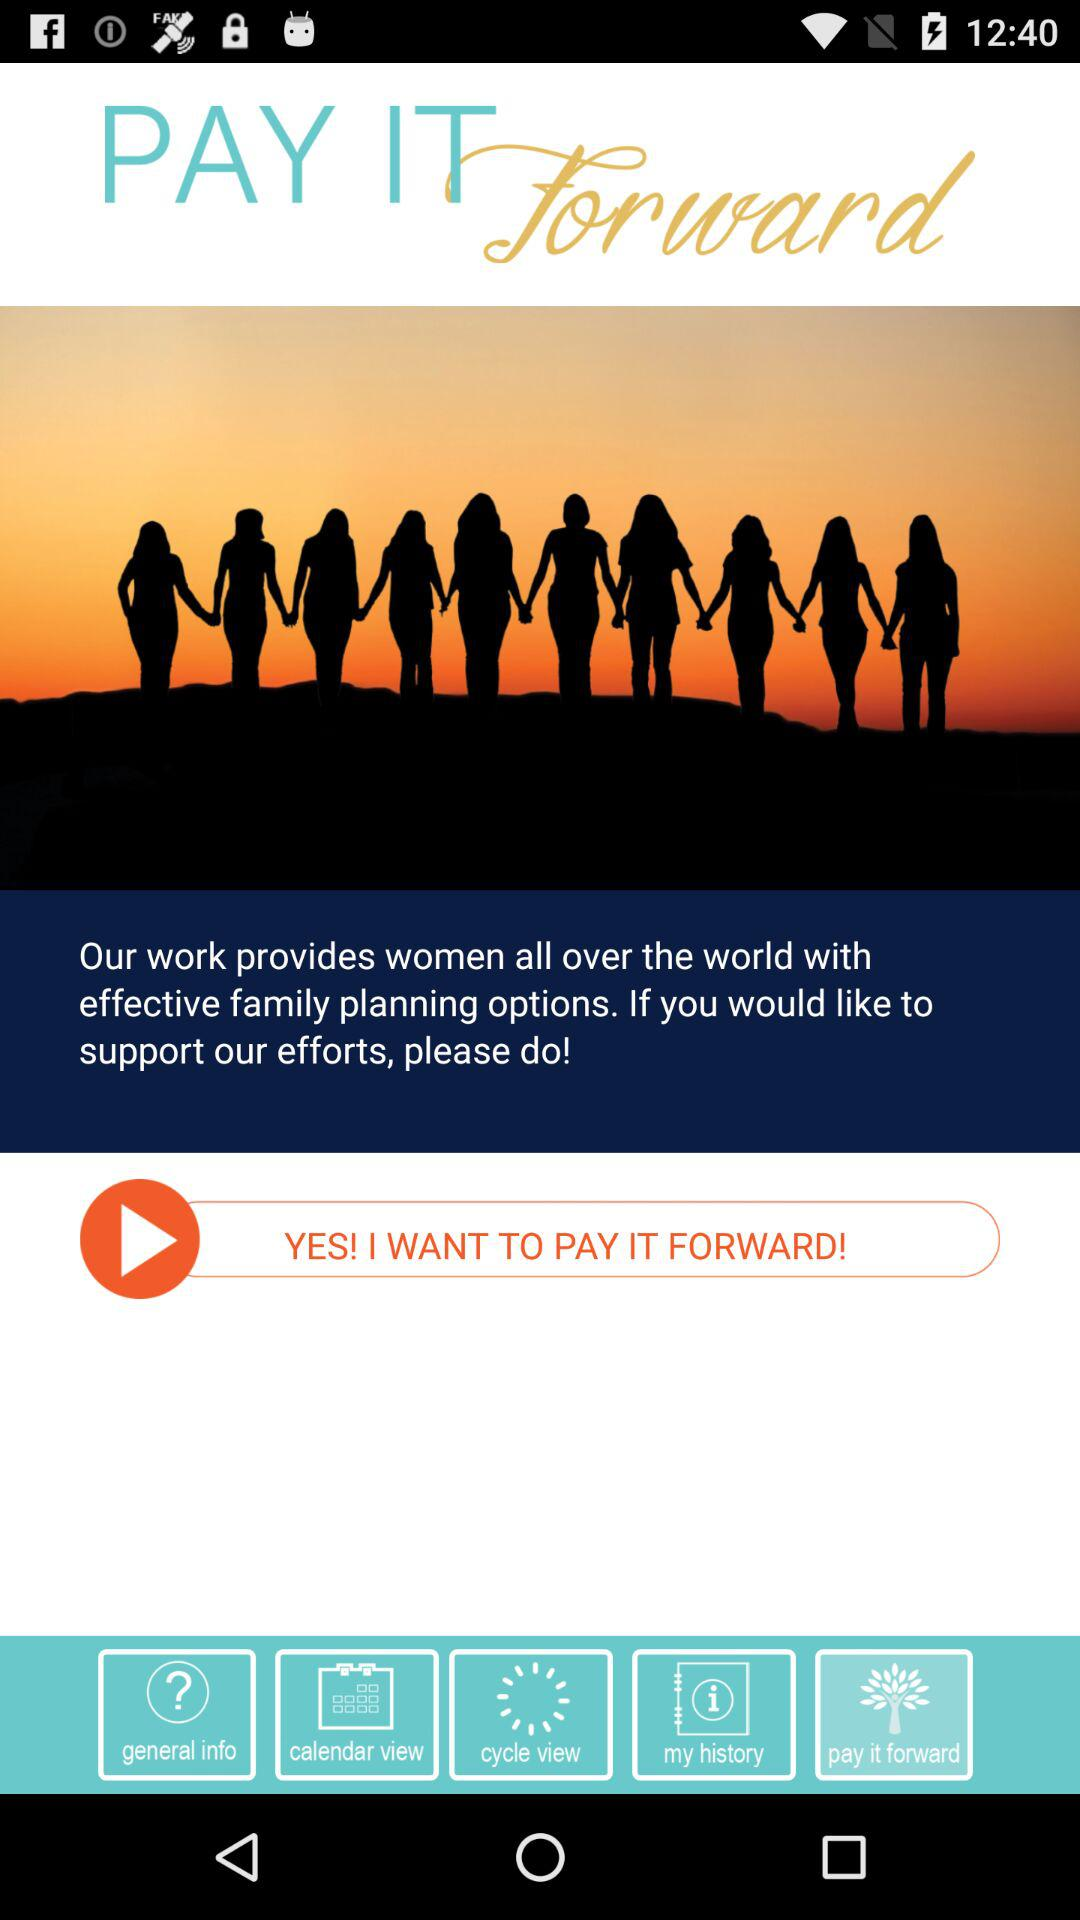Which tab is selected? The tab "pay it forward" is selected. 